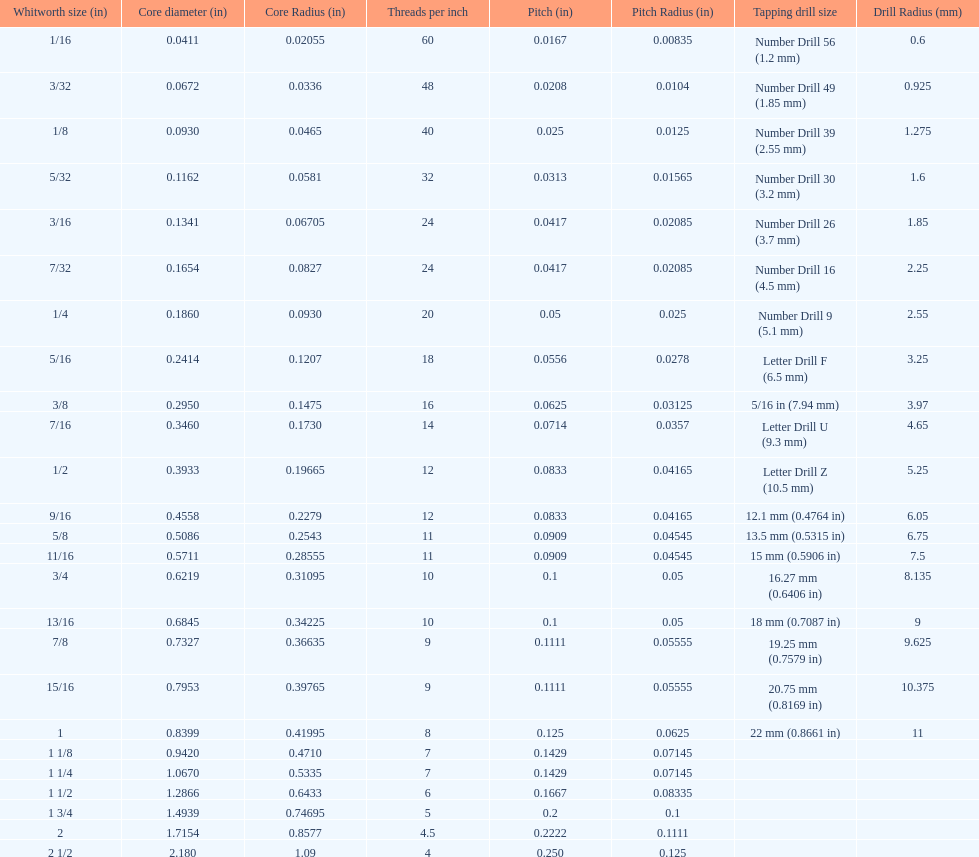What is the greatest number of threads per inch? 60. 